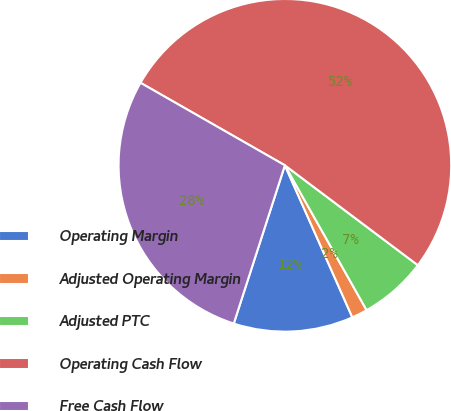<chart> <loc_0><loc_0><loc_500><loc_500><pie_chart><fcel>Operating Margin<fcel>Adjusted Operating Margin<fcel>Adjusted PTC<fcel>Operating Cash Flow<fcel>Free Cash Flow<nl><fcel>11.62%<fcel>1.53%<fcel>6.57%<fcel>51.99%<fcel>28.29%<nl></chart> 